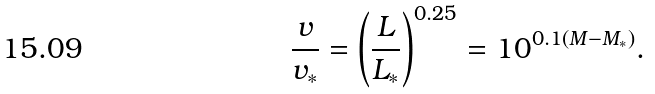<formula> <loc_0><loc_0><loc_500><loc_500>\frac { v } { v _ { * } } = \left ( \frac { L } { L _ { * } } \right ) ^ { 0 . 2 5 } = 1 0 ^ { 0 . 1 ( M - M _ { * } ) } .</formula> 